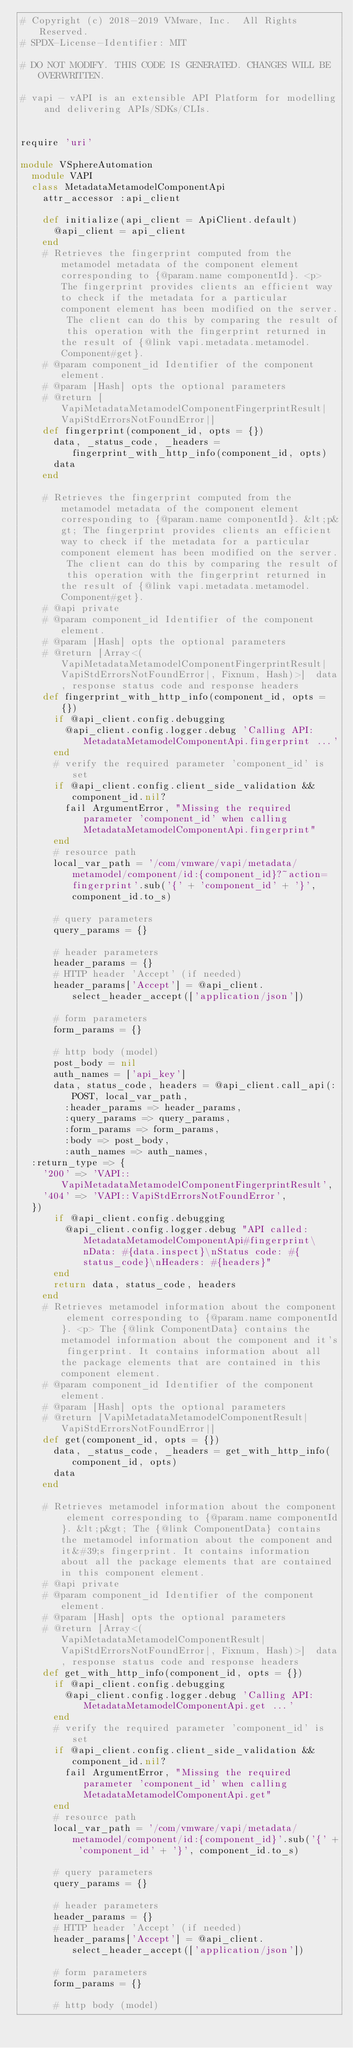Convert code to text. <code><loc_0><loc_0><loc_500><loc_500><_Ruby_># Copyright (c) 2018-2019 VMware, Inc.  All Rights Reserved.
# SPDX-License-Identifier: MIT

# DO NOT MODIFY. THIS CODE IS GENERATED. CHANGES WILL BE OVERWRITTEN.

# vapi - vAPI is an extensible API Platform for modelling and delivering APIs/SDKs/CLIs.


require 'uri'

module VSphereAutomation
  module VAPI
  class MetadataMetamodelComponentApi
    attr_accessor :api_client

    def initialize(api_client = ApiClient.default)
      @api_client = api_client
    end
    # Retrieves the fingerprint computed from the metamodel metadata of the component element corresponding to {@param.name componentId}. <p> The fingerprint provides clients an efficient way to check if the metadata for a particular component element has been modified on the server. The client can do this by comparing the result of this operation with the fingerprint returned in the result of {@link vapi.metadata.metamodel.Component#get}.
    # @param component_id Identifier of the component element.
    # @param [Hash] opts the optional parameters
    # @return [VapiMetadataMetamodelComponentFingerprintResult|VapiStdErrorsNotFoundError|]
    def fingerprint(component_id, opts = {})
      data, _status_code, _headers = fingerprint_with_http_info(component_id, opts)
      data
    end

    # Retrieves the fingerprint computed from the metamodel metadata of the component element corresponding to {@param.name componentId}. &lt;p&gt; The fingerprint provides clients an efficient way to check if the metadata for a particular component element has been modified on the server. The client can do this by comparing the result of this operation with the fingerprint returned in the result of {@link vapi.metadata.metamodel.Component#get}.
    # @api private
    # @param component_id Identifier of the component element.
    # @param [Hash] opts the optional parameters
    # @return [Array<(VapiMetadataMetamodelComponentFingerprintResult|VapiStdErrorsNotFoundError|, Fixnum, Hash)>]  data, response status code and response headers
    def fingerprint_with_http_info(component_id, opts = {})
      if @api_client.config.debugging
        @api_client.config.logger.debug 'Calling API: MetadataMetamodelComponentApi.fingerprint ...'
      end
      # verify the required parameter 'component_id' is set
      if @api_client.config.client_side_validation && component_id.nil?
        fail ArgumentError, "Missing the required parameter 'component_id' when calling MetadataMetamodelComponentApi.fingerprint"
      end
      # resource path
      local_var_path = '/com/vmware/vapi/metadata/metamodel/component/id:{component_id}?~action=fingerprint'.sub('{' + 'component_id' + '}', component_id.to_s)

      # query parameters
      query_params = {}

      # header parameters
      header_params = {}
      # HTTP header 'Accept' (if needed)
      header_params['Accept'] = @api_client.select_header_accept(['application/json'])

      # form parameters
      form_params = {}

      # http body (model)
      post_body = nil
      auth_names = ['api_key']
      data, status_code, headers = @api_client.call_api(:POST, local_var_path,
        :header_params => header_params,
        :query_params => query_params,
        :form_params => form_params,
        :body => post_body,
        :auth_names => auth_names,
	:return_type => {
	  '200' => 'VAPI::VapiMetadataMetamodelComponentFingerprintResult',
	  '404' => 'VAPI::VapiStdErrorsNotFoundError',
	})
      if @api_client.config.debugging
        @api_client.config.logger.debug "API called: MetadataMetamodelComponentApi#fingerprint\nData: #{data.inspect}\nStatus code: #{status_code}\nHeaders: #{headers}"
      end
      return data, status_code, headers
    end
    # Retrieves metamodel information about the component element corresponding to {@param.name componentId}. <p> The {@link ComponentData} contains the metamodel information about the component and it's fingerprint. It contains information about all the package elements that are contained in this component element.
    # @param component_id Identifier of the component element.
    # @param [Hash] opts the optional parameters
    # @return [VapiMetadataMetamodelComponentResult|VapiStdErrorsNotFoundError|]
    def get(component_id, opts = {})
      data, _status_code, _headers = get_with_http_info(component_id, opts)
      data
    end

    # Retrieves metamodel information about the component element corresponding to {@param.name componentId}. &lt;p&gt; The {@link ComponentData} contains the metamodel information about the component and it&#39;s fingerprint. It contains information about all the package elements that are contained in this component element.
    # @api private
    # @param component_id Identifier of the component element.
    # @param [Hash] opts the optional parameters
    # @return [Array<(VapiMetadataMetamodelComponentResult|VapiStdErrorsNotFoundError|, Fixnum, Hash)>]  data, response status code and response headers
    def get_with_http_info(component_id, opts = {})
      if @api_client.config.debugging
        @api_client.config.logger.debug 'Calling API: MetadataMetamodelComponentApi.get ...'
      end
      # verify the required parameter 'component_id' is set
      if @api_client.config.client_side_validation && component_id.nil?
        fail ArgumentError, "Missing the required parameter 'component_id' when calling MetadataMetamodelComponentApi.get"
      end
      # resource path
      local_var_path = '/com/vmware/vapi/metadata/metamodel/component/id:{component_id}'.sub('{' + 'component_id' + '}', component_id.to_s)

      # query parameters
      query_params = {}

      # header parameters
      header_params = {}
      # HTTP header 'Accept' (if needed)
      header_params['Accept'] = @api_client.select_header_accept(['application/json'])

      # form parameters
      form_params = {}

      # http body (model)</code> 